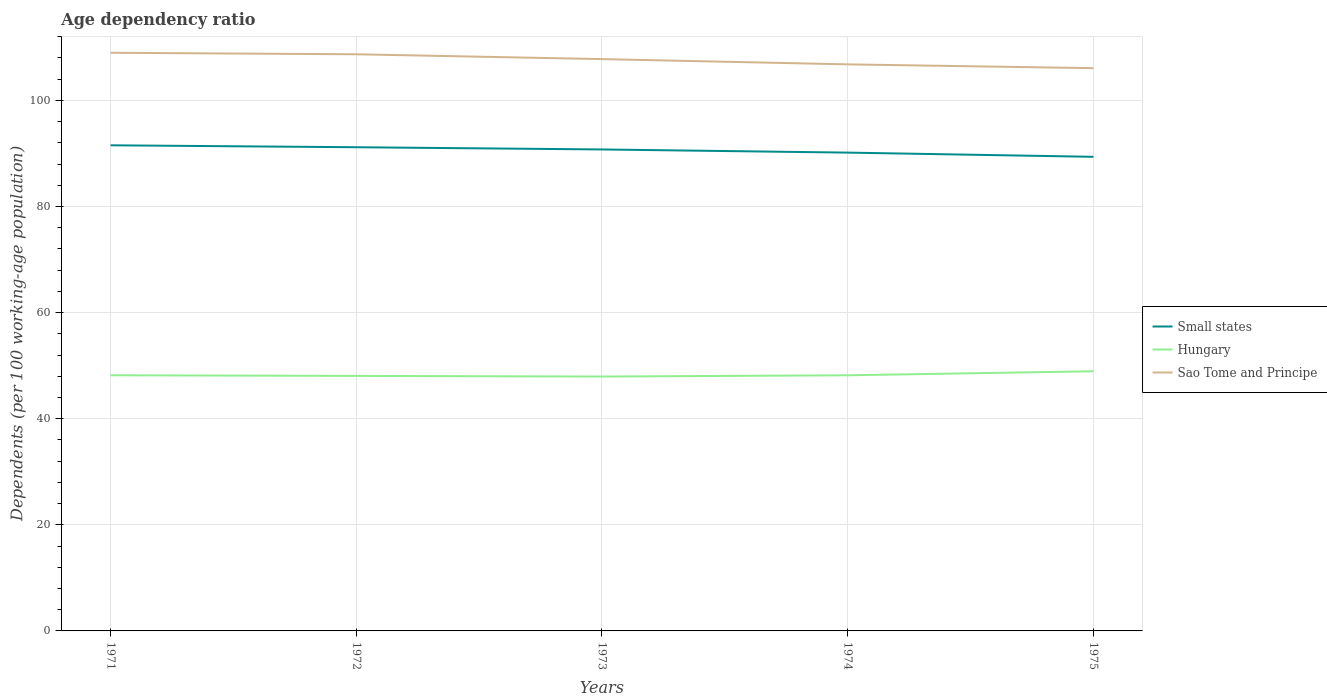How many different coloured lines are there?
Your answer should be very brief. 3. Is the number of lines equal to the number of legend labels?
Provide a succinct answer. Yes. Across all years, what is the maximum age dependency ratio in in Hungary?
Offer a very short reply. 47.95. In which year was the age dependency ratio in in Sao Tome and Principe maximum?
Keep it short and to the point. 1975. What is the total age dependency ratio in in Small states in the graph?
Give a very brief answer. 1.39. What is the difference between the highest and the second highest age dependency ratio in in Hungary?
Keep it short and to the point. 0.99. What is the difference between the highest and the lowest age dependency ratio in in Sao Tome and Principe?
Your answer should be very brief. 3. How many lines are there?
Offer a terse response. 3. Does the graph contain any zero values?
Ensure brevity in your answer.  No. Where does the legend appear in the graph?
Give a very brief answer. Center right. How many legend labels are there?
Your response must be concise. 3. What is the title of the graph?
Give a very brief answer. Age dependency ratio. Does "Finland" appear as one of the legend labels in the graph?
Your response must be concise. No. What is the label or title of the X-axis?
Make the answer very short. Years. What is the label or title of the Y-axis?
Provide a short and direct response. Dependents (per 100 working-age population). What is the Dependents (per 100 working-age population) in Small states in 1971?
Ensure brevity in your answer.  91.53. What is the Dependents (per 100 working-age population) in Hungary in 1971?
Offer a very short reply. 48.19. What is the Dependents (per 100 working-age population) in Sao Tome and Principe in 1971?
Your response must be concise. 108.97. What is the Dependents (per 100 working-age population) in Small states in 1972?
Offer a very short reply. 91.17. What is the Dependents (per 100 working-age population) in Hungary in 1972?
Your response must be concise. 48.07. What is the Dependents (per 100 working-age population) of Sao Tome and Principe in 1972?
Your response must be concise. 108.69. What is the Dependents (per 100 working-age population) of Small states in 1973?
Offer a terse response. 90.75. What is the Dependents (per 100 working-age population) in Hungary in 1973?
Make the answer very short. 47.95. What is the Dependents (per 100 working-age population) of Sao Tome and Principe in 1973?
Provide a succinct answer. 107.78. What is the Dependents (per 100 working-age population) in Small states in 1974?
Make the answer very short. 90.15. What is the Dependents (per 100 working-age population) in Hungary in 1974?
Ensure brevity in your answer.  48.18. What is the Dependents (per 100 working-age population) in Sao Tome and Principe in 1974?
Your answer should be compact. 106.79. What is the Dependents (per 100 working-age population) of Small states in 1975?
Provide a short and direct response. 89.36. What is the Dependents (per 100 working-age population) in Hungary in 1975?
Ensure brevity in your answer.  48.94. What is the Dependents (per 100 working-age population) of Sao Tome and Principe in 1975?
Make the answer very short. 106.07. Across all years, what is the maximum Dependents (per 100 working-age population) in Small states?
Make the answer very short. 91.53. Across all years, what is the maximum Dependents (per 100 working-age population) in Hungary?
Keep it short and to the point. 48.94. Across all years, what is the maximum Dependents (per 100 working-age population) in Sao Tome and Principe?
Give a very brief answer. 108.97. Across all years, what is the minimum Dependents (per 100 working-age population) of Small states?
Your answer should be very brief. 89.36. Across all years, what is the minimum Dependents (per 100 working-age population) of Hungary?
Make the answer very short. 47.95. Across all years, what is the minimum Dependents (per 100 working-age population) in Sao Tome and Principe?
Your answer should be very brief. 106.07. What is the total Dependents (per 100 working-age population) of Small states in the graph?
Make the answer very short. 452.97. What is the total Dependents (per 100 working-age population) in Hungary in the graph?
Your answer should be very brief. 241.32. What is the total Dependents (per 100 working-age population) of Sao Tome and Principe in the graph?
Offer a very short reply. 538.3. What is the difference between the Dependents (per 100 working-age population) of Small states in 1971 and that in 1972?
Provide a succinct answer. 0.36. What is the difference between the Dependents (per 100 working-age population) in Hungary in 1971 and that in 1972?
Your answer should be compact. 0.12. What is the difference between the Dependents (per 100 working-age population) of Sao Tome and Principe in 1971 and that in 1972?
Provide a short and direct response. 0.29. What is the difference between the Dependents (per 100 working-age population) in Small states in 1971 and that in 1973?
Your answer should be very brief. 0.78. What is the difference between the Dependents (per 100 working-age population) of Hungary in 1971 and that in 1973?
Make the answer very short. 0.24. What is the difference between the Dependents (per 100 working-age population) in Sao Tome and Principe in 1971 and that in 1973?
Give a very brief answer. 1.2. What is the difference between the Dependents (per 100 working-age population) of Small states in 1971 and that in 1974?
Your answer should be very brief. 1.38. What is the difference between the Dependents (per 100 working-age population) in Hungary in 1971 and that in 1974?
Offer a very short reply. 0. What is the difference between the Dependents (per 100 working-age population) of Sao Tome and Principe in 1971 and that in 1974?
Your answer should be compact. 2.19. What is the difference between the Dependents (per 100 working-age population) of Small states in 1971 and that in 1975?
Your answer should be compact. 2.17. What is the difference between the Dependents (per 100 working-age population) of Hungary in 1971 and that in 1975?
Provide a succinct answer. -0.76. What is the difference between the Dependents (per 100 working-age population) of Sao Tome and Principe in 1971 and that in 1975?
Give a very brief answer. 2.9. What is the difference between the Dependents (per 100 working-age population) in Small states in 1972 and that in 1973?
Offer a terse response. 0.42. What is the difference between the Dependents (per 100 working-age population) of Hungary in 1972 and that in 1973?
Provide a succinct answer. 0.12. What is the difference between the Dependents (per 100 working-age population) in Sao Tome and Principe in 1972 and that in 1973?
Make the answer very short. 0.91. What is the difference between the Dependents (per 100 working-age population) in Small states in 1972 and that in 1974?
Give a very brief answer. 1.01. What is the difference between the Dependents (per 100 working-age population) of Hungary in 1972 and that in 1974?
Ensure brevity in your answer.  -0.12. What is the difference between the Dependents (per 100 working-age population) of Sao Tome and Principe in 1972 and that in 1974?
Ensure brevity in your answer.  1.9. What is the difference between the Dependents (per 100 working-age population) in Small states in 1972 and that in 1975?
Give a very brief answer. 1.81. What is the difference between the Dependents (per 100 working-age population) of Hungary in 1972 and that in 1975?
Make the answer very short. -0.87. What is the difference between the Dependents (per 100 working-age population) of Sao Tome and Principe in 1972 and that in 1975?
Offer a very short reply. 2.62. What is the difference between the Dependents (per 100 working-age population) in Small states in 1973 and that in 1974?
Your answer should be compact. 0.59. What is the difference between the Dependents (per 100 working-age population) in Hungary in 1973 and that in 1974?
Give a very brief answer. -0.24. What is the difference between the Dependents (per 100 working-age population) of Small states in 1973 and that in 1975?
Your response must be concise. 1.39. What is the difference between the Dependents (per 100 working-age population) of Hungary in 1973 and that in 1975?
Your response must be concise. -0.99. What is the difference between the Dependents (per 100 working-age population) of Sao Tome and Principe in 1973 and that in 1975?
Provide a succinct answer. 1.71. What is the difference between the Dependents (per 100 working-age population) in Small states in 1974 and that in 1975?
Your answer should be very brief. 0.79. What is the difference between the Dependents (per 100 working-age population) of Hungary in 1974 and that in 1975?
Offer a very short reply. -0.76. What is the difference between the Dependents (per 100 working-age population) in Sao Tome and Principe in 1974 and that in 1975?
Provide a succinct answer. 0.72. What is the difference between the Dependents (per 100 working-age population) of Small states in 1971 and the Dependents (per 100 working-age population) of Hungary in 1972?
Offer a terse response. 43.47. What is the difference between the Dependents (per 100 working-age population) of Small states in 1971 and the Dependents (per 100 working-age population) of Sao Tome and Principe in 1972?
Give a very brief answer. -17.16. What is the difference between the Dependents (per 100 working-age population) of Hungary in 1971 and the Dependents (per 100 working-age population) of Sao Tome and Principe in 1972?
Offer a terse response. -60.5. What is the difference between the Dependents (per 100 working-age population) in Small states in 1971 and the Dependents (per 100 working-age population) in Hungary in 1973?
Your answer should be very brief. 43.59. What is the difference between the Dependents (per 100 working-age population) of Small states in 1971 and the Dependents (per 100 working-age population) of Sao Tome and Principe in 1973?
Provide a short and direct response. -16.25. What is the difference between the Dependents (per 100 working-age population) of Hungary in 1971 and the Dependents (per 100 working-age population) of Sao Tome and Principe in 1973?
Ensure brevity in your answer.  -59.59. What is the difference between the Dependents (per 100 working-age population) in Small states in 1971 and the Dependents (per 100 working-age population) in Hungary in 1974?
Make the answer very short. 43.35. What is the difference between the Dependents (per 100 working-age population) of Small states in 1971 and the Dependents (per 100 working-age population) of Sao Tome and Principe in 1974?
Keep it short and to the point. -15.26. What is the difference between the Dependents (per 100 working-age population) of Hungary in 1971 and the Dependents (per 100 working-age population) of Sao Tome and Principe in 1974?
Offer a very short reply. -58.6. What is the difference between the Dependents (per 100 working-age population) of Small states in 1971 and the Dependents (per 100 working-age population) of Hungary in 1975?
Keep it short and to the point. 42.59. What is the difference between the Dependents (per 100 working-age population) in Small states in 1971 and the Dependents (per 100 working-age population) in Sao Tome and Principe in 1975?
Provide a succinct answer. -14.54. What is the difference between the Dependents (per 100 working-age population) in Hungary in 1971 and the Dependents (per 100 working-age population) in Sao Tome and Principe in 1975?
Offer a very short reply. -57.88. What is the difference between the Dependents (per 100 working-age population) of Small states in 1972 and the Dependents (per 100 working-age population) of Hungary in 1973?
Give a very brief answer. 43.22. What is the difference between the Dependents (per 100 working-age population) in Small states in 1972 and the Dependents (per 100 working-age population) in Sao Tome and Principe in 1973?
Offer a terse response. -16.61. What is the difference between the Dependents (per 100 working-age population) in Hungary in 1972 and the Dependents (per 100 working-age population) in Sao Tome and Principe in 1973?
Ensure brevity in your answer.  -59.71. What is the difference between the Dependents (per 100 working-age population) of Small states in 1972 and the Dependents (per 100 working-age population) of Hungary in 1974?
Your answer should be compact. 42.98. What is the difference between the Dependents (per 100 working-age population) of Small states in 1972 and the Dependents (per 100 working-age population) of Sao Tome and Principe in 1974?
Keep it short and to the point. -15.62. What is the difference between the Dependents (per 100 working-age population) of Hungary in 1972 and the Dependents (per 100 working-age population) of Sao Tome and Principe in 1974?
Offer a very short reply. -58.72. What is the difference between the Dependents (per 100 working-age population) of Small states in 1972 and the Dependents (per 100 working-age population) of Hungary in 1975?
Offer a very short reply. 42.23. What is the difference between the Dependents (per 100 working-age population) in Small states in 1972 and the Dependents (per 100 working-age population) in Sao Tome and Principe in 1975?
Provide a short and direct response. -14.9. What is the difference between the Dependents (per 100 working-age population) of Hungary in 1972 and the Dependents (per 100 working-age population) of Sao Tome and Principe in 1975?
Give a very brief answer. -58. What is the difference between the Dependents (per 100 working-age population) in Small states in 1973 and the Dependents (per 100 working-age population) in Hungary in 1974?
Give a very brief answer. 42.56. What is the difference between the Dependents (per 100 working-age population) of Small states in 1973 and the Dependents (per 100 working-age population) of Sao Tome and Principe in 1974?
Offer a terse response. -16.04. What is the difference between the Dependents (per 100 working-age population) of Hungary in 1973 and the Dependents (per 100 working-age population) of Sao Tome and Principe in 1974?
Your answer should be very brief. -58.84. What is the difference between the Dependents (per 100 working-age population) in Small states in 1973 and the Dependents (per 100 working-age population) in Hungary in 1975?
Provide a short and direct response. 41.81. What is the difference between the Dependents (per 100 working-age population) in Small states in 1973 and the Dependents (per 100 working-age population) in Sao Tome and Principe in 1975?
Offer a very short reply. -15.32. What is the difference between the Dependents (per 100 working-age population) of Hungary in 1973 and the Dependents (per 100 working-age population) of Sao Tome and Principe in 1975?
Ensure brevity in your answer.  -58.12. What is the difference between the Dependents (per 100 working-age population) of Small states in 1974 and the Dependents (per 100 working-age population) of Hungary in 1975?
Keep it short and to the point. 41.21. What is the difference between the Dependents (per 100 working-age population) of Small states in 1974 and the Dependents (per 100 working-age population) of Sao Tome and Principe in 1975?
Ensure brevity in your answer.  -15.91. What is the difference between the Dependents (per 100 working-age population) of Hungary in 1974 and the Dependents (per 100 working-age population) of Sao Tome and Principe in 1975?
Ensure brevity in your answer.  -57.88. What is the average Dependents (per 100 working-age population) in Small states per year?
Offer a very short reply. 90.59. What is the average Dependents (per 100 working-age population) of Hungary per year?
Provide a succinct answer. 48.26. What is the average Dependents (per 100 working-age population) in Sao Tome and Principe per year?
Provide a succinct answer. 107.66. In the year 1971, what is the difference between the Dependents (per 100 working-age population) of Small states and Dependents (per 100 working-age population) of Hungary?
Provide a short and direct response. 43.35. In the year 1971, what is the difference between the Dependents (per 100 working-age population) of Small states and Dependents (per 100 working-age population) of Sao Tome and Principe?
Give a very brief answer. -17.44. In the year 1971, what is the difference between the Dependents (per 100 working-age population) of Hungary and Dependents (per 100 working-age population) of Sao Tome and Principe?
Make the answer very short. -60.79. In the year 1972, what is the difference between the Dependents (per 100 working-age population) in Small states and Dependents (per 100 working-age population) in Hungary?
Offer a very short reply. 43.1. In the year 1972, what is the difference between the Dependents (per 100 working-age population) in Small states and Dependents (per 100 working-age population) in Sao Tome and Principe?
Keep it short and to the point. -17.52. In the year 1972, what is the difference between the Dependents (per 100 working-age population) in Hungary and Dependents (per 100 working-age population) in Sao Tome and Principe?
Offer a terse response. -60.62. In the year 1973, what is the difference between the Dependents (per 100 working-age population) of Small states and Dependents (per 100 working-age population) of Hungary?
Provide a short and direct response. 42.8. In the year 1973, what is the difference between the Dependents (per 100 working-age population) in Small states and Dependents (per 100 working-age population) in Sao Tome and Principe?
Provide a succinct answer. -17.03. In the year 1973, what is the difference between the Dependents (per 100 working-age population) in Hungary and Dependents (per 100 working-age population) in Sao Tome and Principe?
Your answer should be very brief. -59.83. In the year 1974, what is the difference between the Dependents (per 100 working-age population) of Small states and Dependents (per 100 working-age population) of Hungary?
Make the answer very short. 41.97. In the year 1974, what is the difference between the Dependents (per 100 working-age population) of Small states and Dependents (per 100 working-age population) of Sao Tome and Principe?
Make the answer very short. -16.63. In the year 1974, what is the difference between the Dependents (per 100 working-age population) of Hungary and Dependents (per 100 working-age population) of Sao Tome and Principe?
Offer a terse response. -58.6. In the year 1975, what is the difference between the Dependents (per 100 working-age population) of Small states and Dependents (per 100 working-age population) of Hungary?
Give a very brief answer. 40.42. In the year 1975, what is the difference between the Dependents (per 100 working-age population) in Small states and Dependents (per 100 working-age population) in Sao Tome and Principe?
Give a very brief answer. -16.71. In the year 1975, what is the difference between the Dependents (per 100 working-age population) of Hungary and Dependents (per 100 working-age population) of Sao Tome and Principe?
Ensure brevity in your answer.  -57.13. What is the ratio of the Dependents (per 100 working-age population) in Hungary in 1971 to that in 1972?
Your response must be concise. 1. What is the ratio of the Dependents (per 100 working-age population) of Sao Tome and Principe in 1971 to that in 1972?
Offer a terse response. 1. What is the ratio of the Dependents (per 100 working-age population) in Small states in 1971 to that in 1973?
Ensure brevity in your answer.  1.01. What is the ratio of the Dependents (per 100 working-age population) of Hungary in 1971 to that in 1973?
Give a very brief answer. 1. What is the ratio of the Dependents (per 100 working-age population) of Sao Tome and Principe in 1971 to that in 1973?
Give a very brief answer. 1.01. What is the ratio of the Dependents (per 100 working-age population) in Small states in 1971 to that in 1974?
Offer a terse response. 1.02. What is the ratio of the Dependents (per 100 working-age population) of Hungary in 1971 to that in 1974?
Offer a terse response. 1. What is the ratio of the Dependents (per 100 working-age population) in Sao Tome and Principe in 1971 to that in 1974?
Make the answer very short. 1.02. What is the ratio of the Dependents (per 100 working-age population) of Small states in 1971 to that in 1975?
Your response must be concise. 1.02. What is the ratio of the Dependents (per 100 working-age population) of Hungary in 1971 to that in 1975?
Offer a very short reply. 0.98. What is the ratio of the Dependents (per 100 working-age population) in Sao Tome and Principe in 1971 to that in 1975?
Keep it short and to the point. 1.03. What is the ratio of the Dependents (per 100 working-age population) in Small states in 1972 to that in 1973?
Make the answer very short. 1. What is the ratio of the Dependents (per 100 working-age population) of Sao Tome and Principe in 1972 to that in 1973?
Provide a succinct answer. 1.01. What is the ratio of the Dependents (per 100 working-age population) in Small states in 1972 to that in 1974?
Your answer should be compact. 1.01. What is the ratio of the Dependents (per 100 working-age population) in Sao Tome and Principe in 1972 to that in 1974?
Make the answer very short. 1.02. What is the ratio of the Dependents (per 100 working-age population) in Small states in 1972 to that in 1975?
Offer a very short reply. 1.02. What is the ratio of the Dependents (per 100 working-age population) in Hungary in 1972 to that in 1975?
Provide a succinct answer. 0.98. What is the ratio of the Dependents (per 100 working-age population) of Sao Tome and Principe in 1972 to that in 1975?
Your answer should be compact. 1.02. What is the ratio of the Dependents (per 100 working-age population) in Small states in 1973 to that in 1974?
Provide a short and direct response. 1.01. What is the ratio of the Dependents (per 100 working-age population) of Sao Tome and Principe in 1973 to that in 1974?
Your response must be concise. 1.01. What is the ratio of the Dependents (per 100 working-age population) in Small states in 1973 to that in 1975?
Your answer should be very brief. 1.02. What is the ratio of the Dependents (per 100 working-age population) in Hungary in 1973 to that in 1975?
Your answer should be compact. 0.98. What is the ratio of the Dependents (per 100 working-age population) in Sao Tome and Principe in 1973 to that in 1975?
Your answer should be very brief. 1.02. What is the ratio of the Dependents (per 100 working-age population) of Small states in 1974 to that in 1975?
Ensure brevity in your answer.  1.01. What is the ratio of the Dependents (per 100 working-age population) in Hungary in 1974 to that in 1975?
Make the answer very short. 0.98. What is the ratio of the Dependents (per 100 working-age population) in Sao Tome and Principe in 1974 to that in 1975?
Your answer should be compact. 1.01. What is the difference between the highest and the second highest Dependents (per 100 working-age population) in Small states?
Ensure brevity in your answer.  0.36. What is the difference between the highest and the second highest Dependents (per 100 working-age population) of Hungary?
Provide a short and direct response. 0.76. What is the difference between the highest and the second highest Dependents (per 100 working-age population) in Sao Tome and Principe?
Your response must be concise. 0.29. What is the difference between the highest and the lowest Dependents (per 100 working-age population) in Small states?
Offer a terse response. 2.17. What is the difference between the highest and the lowest Dependents (per 100 working-age population) of Sao Tome and Principe?
Keep it short and to the point. 2.9. 